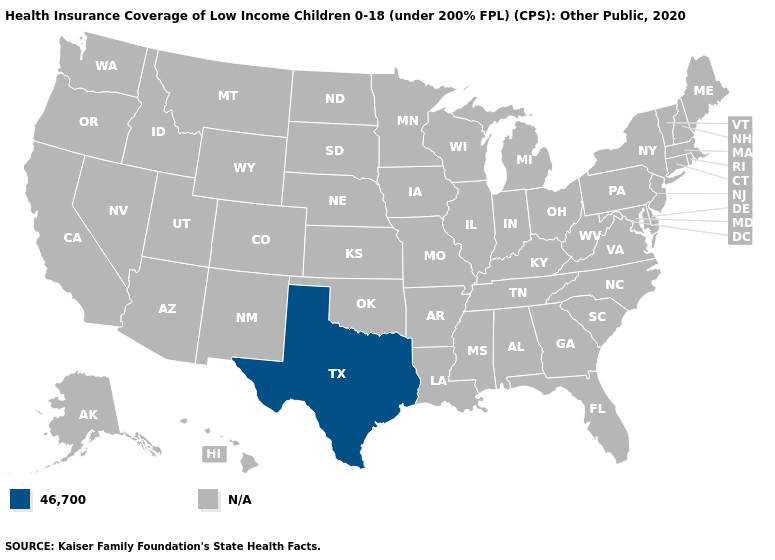What is the lowest value in the South?
Concise answer only. 46,700. What is the value of West Virginia?
Quick response, please. N/A. What is the value of Hawaii?
Concise answer only. N/A. What is the value of New Hampshire?
Keep it brief. N/A. What is the value of Kansas?
Give a very brief answer. N/A. Name the states that have a value in the range 46,700?
Give a very brief answer. Texas. What is the value of Kansas?
Quick response, please. N/A. Name the states that have a value in the range 46,700?
Concise answer only. Texas. What is the value of Ohio?
Answer briefly. N/A. 